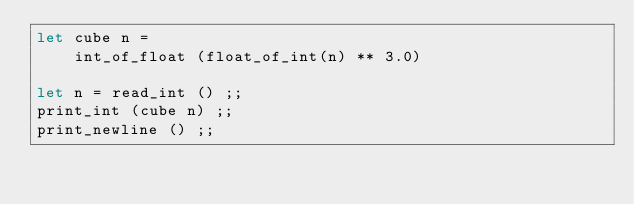Convert code to text. <code><loc_0><loc_0><loc_500><loc_500><_OCaml_>let cube n =
    int_of_float (float_of_int(n) ** 3.0)

let n = read_int () ;;
print_int (cube n) ;;
print_newline () ;;</code> 